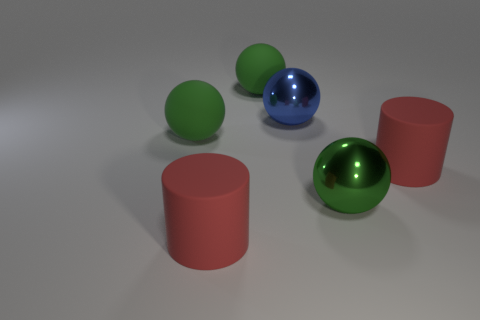Subtract all blue metallic balls. How many balls are left? 3 Add 4 rubber cylinders. How many objects exist? 10 Subtract all green spheres. How many spheres are left? 1 Subtract 0 purple blocks. How many objects are left? 6 Subtract all cylinders. How many objects are left? 4 Subtract 3 balls. How many balls are left? 1 Subtract all yellow cylinders. Subtract all purple balls. How many cylinders are left? 2 Subtract all purple cylinders. How many blue spheres are left? 1 Subtract all brown shiny cylinders. Subtract all big green rubber things. How many objects are left? 4 Add 4 large blue objects. How many large blue objects are left? 5 